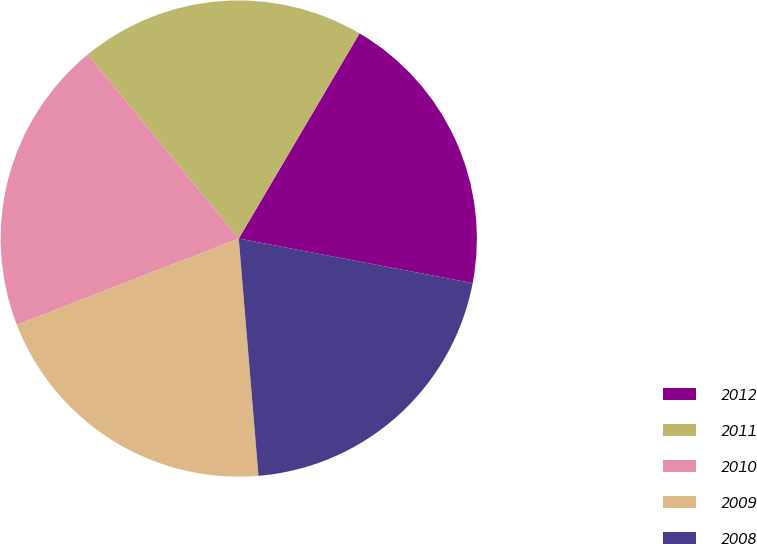<chart> <loc_0><loc_0><loc_500><loc_500><pie_chart><fcel>2012<fcel>2011<fcel>2010<fcel>2009<fcel>2008<nl><fcel>19.53%<fcel>19.4%<fcel>19.96%<fcel>20.42%<fcel>20.68%<nl></chart> 